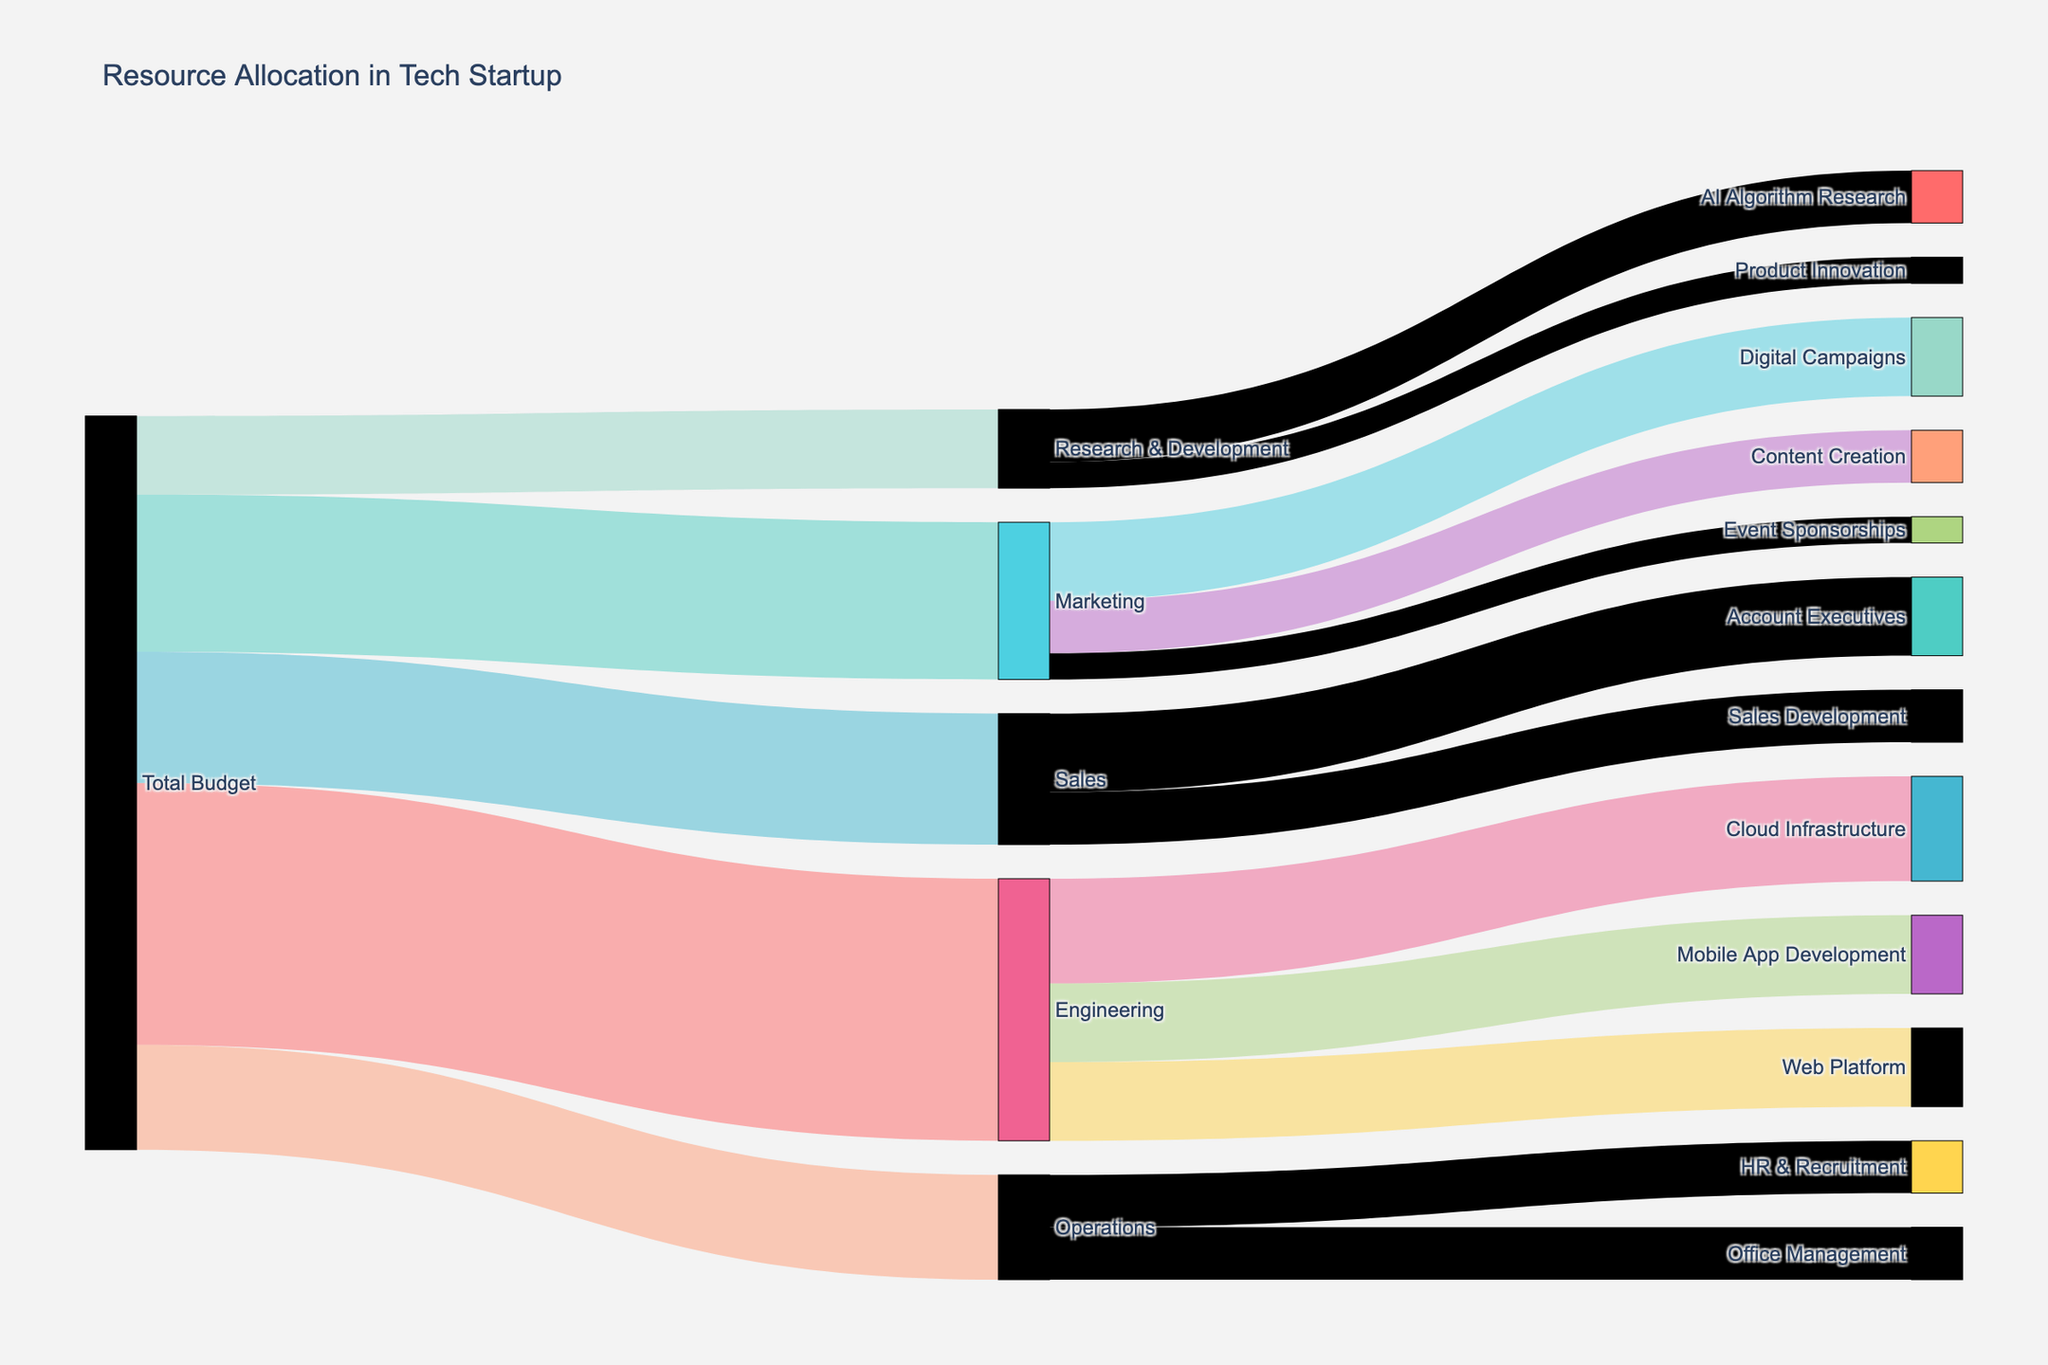Who receives the highest allocation from the total budget? By examining the sum of the values in the links associated with each department, we find that Engineering has the highest allocation at $500,000.
Answer: Engineering Which department has the least funding allocated? By comparing the total allocations for each department, Research & Development receives the least funding at $150,000.
Answer: Research & Development Total how much budget is allocated to Engineering, Marketing, and Sales combined? Summing the allocations for Engineering ($500,000), Marketing ($300,000), and Sales ($250,000), the combined total is $1,050,000.
Answer: $1,050,000 What is the allocated budget for AI Algorithm Research and Product Innovation together? Adding the values for AI Algorithm Research ($100,000) and Product Innovation ($50,000), the total is $150,000.
Answer: $150,000 What is the difference in budget allocation between Cloud Infrastructure and Content Creation? Subtracting the budget for Content Creation ($100,000) from Cloud Infrastructure ($200,000) gives a difference of $100,000.
Answer: $100,000 Which project under Engineering has the smallest budget allocation? By comparing the resources allocated between Cloud Infrastructure ($200,000), Mobile App Development ($150,000), and Web Platform ($150,000), the smallest allocation is Mobile App Development and Web Platform both with $150,000.
Answer: Mobile App Development, Web Platform Between Sales Development and Office Management, which receives a larger budget? Comparing the allocations for Sales Development ($100,000) and Office Management ($100,000), both receive the same budget.
Answer: Same What’s the ratio of the budget allocated to Digital Campaigns compared to Account Executives? The budget for Digital Campaigns is $150,000, and for Account Executives is $150,000, giving a ratio of 1:1.
Answer: 1:1 How does the total allocation for Engineering projects compare to that for Operations projects? The total for Engineering (Cloud Infrastructure, Mobile App Development, Web Platform) is $500,000. For Operations (HR & Recruitment, Office Management), it is $200,000. Engineering receives $300,000 more than Operations.
Answer: $300,000 more 